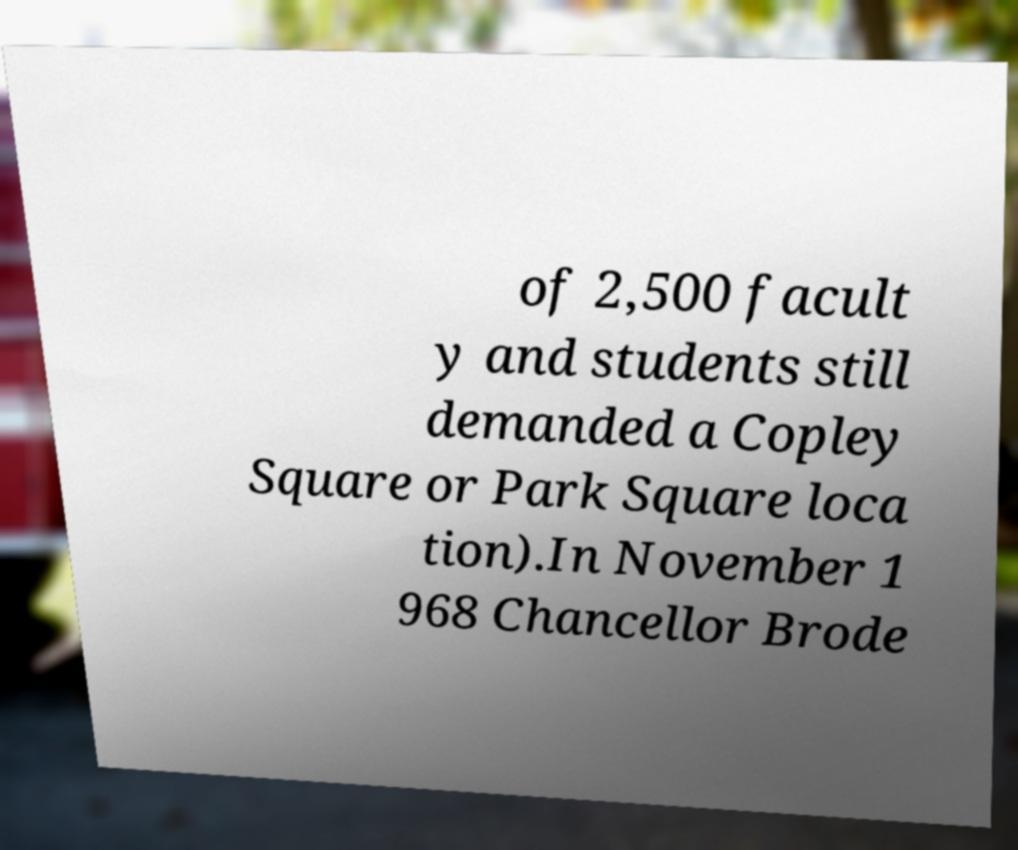Can you accurately transcribe the text from the provided image for me? of 2,500 facult y and students still demanded a Copley Square or Park Square loca tion).In November 1 968 Chancellor Brode 